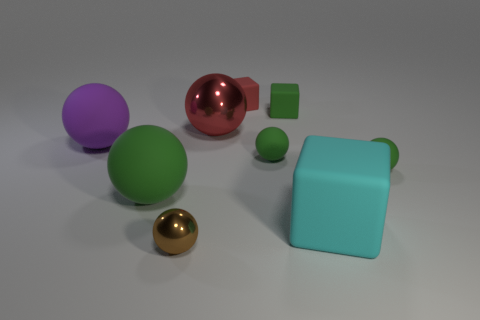Subtract all large green rubber spheres. How many spheres are left? 5 Subtract all gray blocks. How many purple spheres are left? 1 Subtract all green balls. How many balls are left? 3 Subtract all blocks. How many objects are left? 6 Subtract 6 spheres. How many spheres are left? 0 Add 6 matte blocks. How many matte blocks are left? 9 Add 9 brown shiny cylinders. How many brown shiny cylinders exist? 9 Subtract 0 purple cubes. How many objects are left? 9 Subtract all yellow blocks. Subtract all brown spheres. How many blocks are left? 3 Subtract all large cyan matte cubes. Subtract all green matte spheres. How many objects are left? 5 